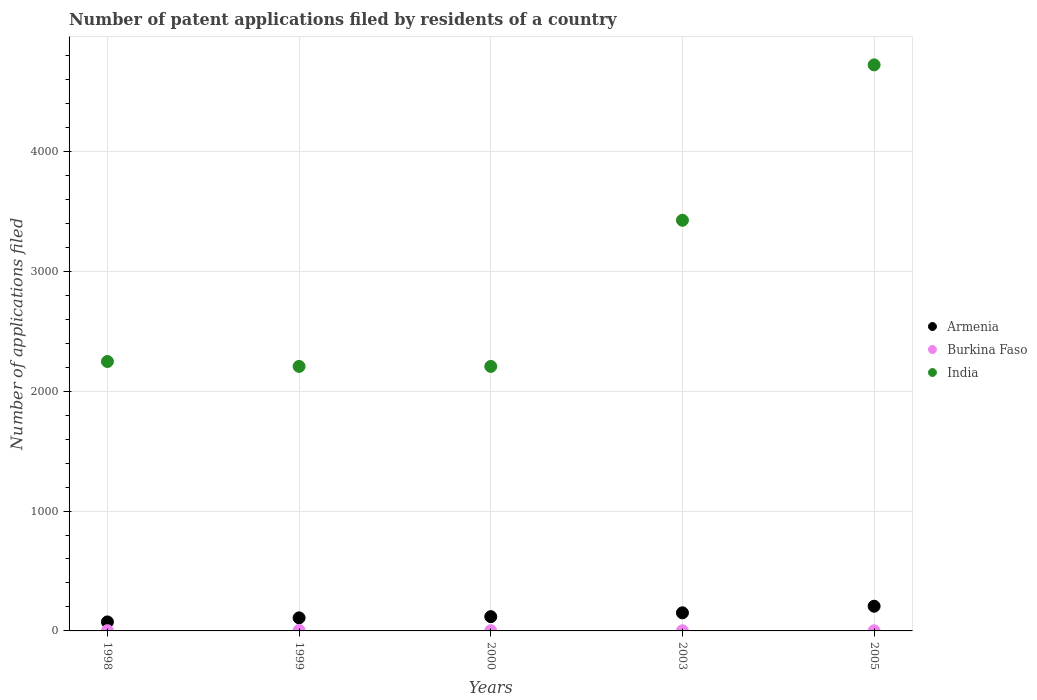How many different coloured dotlines are there?
Your answer should be compact. 3. Is the number of dotlines equal to the number of legend labels?
Your answer should be compact. Yes. What is the number of applications filed in Armenia in 2005?
Offer a terse response. 206. Across all years, what is the maximum number of applications filed in India?
Provide a short and direct response. 4721. What is the total number of applications filed in Burkina Faso in the graph?
Offer a terse response. 10. What is the difference between the number of applications filed in India in 2003 and the number of applications filed in Burkina Faso in 1999?
Provide a succinct answer. 3421. In the year 2005, what is the difference between the number of applications filed in India and number of applications filed in Armenia?
Provide a succinct answer. 4515. In how many years, is the number of applications filed in India greater than 800?
Offer a terse response. 5. What is the ratio of the number of applications filed in India in 2003 to that in 2005?
Ensure brevity in your answer.  0.73. Is the difference between the number of applications filed in India in 2003 and 2005 greater than the difference between the number of applications filed in Armenia in 2003 and 2005?
Make the answer very short. No. What is the difference between the highest and the second highest number of applications filed in India?
Ensure brevity in your answer.  1296. What is the difference between the highest and the lowest number of applications filed in Armenia?
Make the answer very short. 131. In how many years, is the number of applications filed in Burkina Faso greater than the average number of applications filed in Burkina Faso taken over all years?
Provide a short and direct response. 1. How many dotlines are there?
Offer a very short reply. 3. How many years are there in the graph?
Your response must be concise. 5. Are the values on the major ticks of Y-axis written in scientific E-notation?
Your answer should be compact. No. Does the graph contain any zero values?
Offer a very short reply. No. Where does the legend appear in the graph?
Offer a very short reply. Center right. What is the title of the graph?
Give a very brief answer. Number of patent applications filed by residents of a country. Does "Middle East & North Africa (all income levels)" appear as one of the legend labels in the graph?
Your response must be concise. No. What is the label or title of the Y-axis?
Give a very brief answer. Number of applications filed. What is the Number of applications filed of Armenia in 1998?
Your answer should be compact. 75. What is the Number of applications filed of India in 1998?
Keep it short and to the point. 2247. What is the Number of applications filed of Armenia in 1999?
Give a very brief answer. 109. What is the Number of applications filed of India in 1999?
Keep it short and to the point. 2206. What is the Number of applications filed of Armenia in 2000?
Give a very brief answer. 119. What is the Number of applications filed in India in 2000?
Provide a succinct answer. 2206. What is the Number of applications filed in Armenia in 2003?
Make the answer very short. 151. What is the Number of applications filed of Burkina Faso in 2003?
Give a very brief answer. 1. What is the Number of applications filed of India in 2003?
Provide a short and direct response. 3425. What is the Number of applications filed in Armenia in 2005?
Ensure brevity in your answer.  206. What is the Number of applications filed of India in 2005?
Make the answer very short. 4721. Across all years, what is the maximum Number of applications filed in Armenia?
Your response must be concise. 206. Across all years, what is the maximum Number of applications filed in Burkina Faso?
Keep it short and to the point. 4. Across all years, what is the maximum Number of applications filed in India?
Your response must be concise. 4721. Across all years, what is the minimum Number of applications filed of Burkina Faso?
Provide a short and direct response. 1. Across all years, what is the minimum Number of applications filed of India?
Provide a succinct answer. 2206. What is the total Number of applications filed of Armenia in the graph?
Offer a terse response. 660. What is the total Number of applications filed of India in the graph?
Provide a succinct answer. 1.48e+04. What is the difference between the Number of applications filed of Armenia in 1998 and that in 1999?
Provide a short and direct response. -34. What is the difference between the Number of applications filed of Armenia in 1998 and that in 2000?
Your response must be concise. -44. What is the difference between the Number of applications filed of Burkina Faso in 1998 and that in 2000?
Your response must be concise. 0. What is the difference between the Number of applications filed of Armenia in 1998 and that in 2003?
Keep it short and to the point. -76. What is the difference between the Number of applications filed in Burkina Faso in 1998 and that in 2003?
Offer a terse response. 1. What is the difference between the Number of applications filed of India in 1998 and that in 2003?
Your response must be concise. -1178. What is the difference between the Number of applications filed of Armenia in 1998 and that in 2005?
Provide a succinct answer. -131. What is the difference between the Number of applications filed in Burkina Faso in 1998 and that in 2005?
Your answer should be compact. 1. What is the difference between the Number of applications filed in India in 1998 and that in 2005?
Make the answer very short. -2474. What is the difference between the Number of applications filed in Armenia in 1999 and that in 2003?
Make the answer very short. -42. What is the difference between the Number of applications filed in Burkina Faso in 1999 and that in 2003?
Keep it short and to the point. 3. What is the difference between the Number of applications filed of India in 1999 and that in 2003?
Your response must be concise. -1219. What is the difference between the Number of applications filed of Armenia in 1999 and that in 2005?
Provide a succinct answer. -97. What is the difference between the Number of applications filed in India in 1999 and that in 2005?
Make the answer very short. -2515. What is the difference between the Number of applications filed of Armenia in 2000 and that in 2003?
Your answer should be very brief. -32. What is the difference between the Number of applications filed in Burkina Faso in 2000 and that in 2003?
Give a very brief answer. 1. What is the difference between the Number of applications filed of India in 2000 and that in 2003?
Offer a terse response. -1219. What is the difference between the Number of applications filed in Armenia in 2000 and that in 2005?
Keep it short and to the point. -87. What is the difference between the Number of applications filed in India in 2000 and that in 2005?
Provide a short and direct response. -2515. What is the difference between the Number of applications filed of Armenia in 2003 and that in 2005?
Provide a succinct answer. -55. What is the difference between the Number of applications filed of India in 2003 and that in 2005?
Keep it short and to the point. -1296. What is the difference between the Number of applications filed of Armenia in 1998 and the Number of applications filed of India in 1999?
Give a very brief answer. -2131. What is the difference between the Number of applications filed of Burkina Faso in 1998 and the Number of applications filed of India in 1999?
Provide a short and direct response. -2204. What is the difference between the Number of applications filed in Armenia in 1998 and the Number of applications filed in Burkina Faso in 2000?
Your answer should be very brief. 73. What is the difference between the Number of applications filed in Armenia in 1998 and the Number of applications filed in India in 2000?
Your answer should be compact. -2131. What is the difference between the Number of applications filed in Burkina Faso in 1998 and the Number of applications filed in India in 2000?
Give a very brief answer. -2204. What is the difference between the Number of applications filed in Armenia in 1998 and the Number of applications filed in Burkina Faso in 2003?
Provide a succinct answer. 74. What is the difference between the Number of applications filed in Armenia in 1998 and the Number of applications filed in India in 2003?
Ensure brevity in your answer.  -3350. What is the difference between the Number of applications filed of Burkina Faso in 1998 and the Number of applications filed of India in 2003?
Offer a very short reply. -3423. What is the difference between the Number of applications filed of Armenia in 1998 and the Number of applications filed of Burkina Faso in 2005?
Provide a short and direct response. 74. What is the difference between the Number of applications filed of Armenia in 1998 and the Number of applications filed of India in 2005?
Your response must be concise. -4646. What is the difference between the Number of applications filed of Burkina Faso in 1998 and the Number of applications filed of India in 2005?
Provide a short and direct response. -4719. What is the difference between the Number of applications filed in Armenia in 1999 and the Number of applications filed in Burkina Faso in 2000?
Give a very brief answer. 107. What is the difference between the Number of applications filed of Armenia in 1999 and the Number of applications filed of India in 2000?
Your answer should be very brief. -2097. What is the difference between the Number of applications filed in Burkina Faso in 1999 and the Number of applications filed in India in 2000?
Ensure brevity in your answer.  -2202. What is the difference between the Number of applications filed in Armenia in 1999 and the Number of applications filed in Burkina Faso in 2003?
Your answer should be very brief. 108. What is the difference between the Number of applications filed of Armenia in 1999 and the Number of applications filed of India in 2003?
Your answer should be very brief. -3316. What is the difference between the Number of applications filed of Burkina Faso in 1999 and the Number of applications filed of India in 2003?
Provide a short and direct response. -3421. What is the difference between the Number of applications filed in Armenia in 1999 and the Number of applications filed in Burkina Faso in 2005?
Offer a terse response. 108. What is the difference between the Number of applications filed of Armenia in 1999 and the Number of applications filed of India in 2005?
Offer a very short reply. -4612. What is the difference between the Number of applications filed in Burkina Faso in 1999 and the Number of applications filed in India in 2005?
Your response must be concise. -4717. What is the difference between the Number of applications filed in Armenia in 2000 and the Number of applications filed in Burkina Faso in 2003?
Your answer should be compact. 118. What is the difference between the Number of applications filed in Armenia in 2000 and the Number of applications filed in India in 2003?
Keep it short and to the point. -3306. What is the difference between the Number of applications filed of Burkina Faso in 2000 and the Number of applications filed of India in 2003?
Make the answer very short. -3423. What is the difference between the Number of applications filed in Armenia in 2000 and the Number of applications filed in Burkina Faso in 2005?
Provide a succinct answer. 118. What is the difference between the Number of applications filed of Armenia in 2000 and the Number of applications filed of India in 2005?
Offer a terse response. -4602. What is the difference between the Number of applications filed of Burkina Faso in 2000 and the Number of applications filed of India in 2005?
Provide a succinct answer. -4719. What is the difference between the Number of applications filed of Armenia in 2003 and the Number of applications filed of Burkina Faso in 2005?
Offer a very short reply. 150. What is the difference between the Number of applications filed in Armenia in 2003 and the Number of applications filed in India in 2005?
Offer a terse response. -4570. What is the difference between the Number of applications filed in Burkina Faso in 2003 and the Number of applications filed in India in 2005?
Ensure brevity in your answer.  -4720. What is the average Number of applications filed in Armenia per year?
Your response must be concise. 132. What is the average Number of applications filed in India per year?
Your answer should be very brief. 2961. In the year 1998, what is the difference between the Number of applications filed in Armenia and Number of applications filed in Burkina Faso?
Make the answer very short. 73. In the year 1998, what is the difference between the Number of applications filed in Armenia and Number of applications filed in India?
Give a very brief answer. -2172. In the year 1998, what is the difference between the Number of applications filed in Burkina Faso and Number of applications filed in India?
Provide a succinct answer. -2245. In the year 1999, what is the difference between the Number of applications filed in Armenia and Number of applications filed in Burkina Faso?
Offer a terse response. 105. In the year 1999, what is the difference between the Number of applications filed in Armenia and Number of applications filed in India?
Offer a terse response. -2097. In the year 1999, what is the difference between the Number of applications filed of Burkina Faso and Number of applications filed of India?
Offer a very short reply. -2202. In the year 2000, what is the difference between the Number of applications filed in Armenia and Number of applications filed in Burkina Faso?
Ensure brevity in your answer.  117. In the year 2000, what is the difference between the Number of applications filed of Armenia and Number of applications filed of India?
Your answer should be very brief. -2087. In the year 2000, what is the difference between the Number of applications filed in Burkina Faso and Number of applications filed in India?
Make the answer very short. -2204. In the year 2003, what is the difference between the Number of applications filed of Armenia and Number of applications filed of Burkina Faso?
Your response must be concise. 150. In the year 2003, what is the difference between the Number of applications filed in Armenia and Number of applications filed in India?
Your answer should be compact. -3274. In the year 2003, what is the difference between the Number of applications filed of Burkina Faso and Number of applications filed of India?
Offer a very short reply. -3424. In the year 2005, what is the difference between the Number of applications filed in Armenia and Number of applications filed in Burkina Faso?
Your answer should be very brief. 205. In the year 2005, what is the difference between the Number of applications filed of Armenia and Number of applications filed of India?
Provide a succinct answer. -4515. In the year 2005, what is the difference between the Number of applications filed of Burkina Faso and Number of applications filed of India?
Offer a terse response. -4720. What is the ratio of the Number of applications filed in Armenia in 1998 to that in 1999?
Keep it short and to the point. 0.69. What is the ratio of the Number of applications filed of India in 1998 to that in 1999?
Your answer should be compact. 1.02. What is the ratio of the Number of applications filed of Armenia in 1998 to that in 2000?
Offer a very short reply. 0.63. What is the ratio of the Number of applications filed of India in 1998 to that in 2000?
Offer a very short reply. 1.02. What is the ratio of the Number of applications filed of Armenia in 1998 to that in 2003?
Your response must be concise. 0.5. What is the ratio of the Number of applications filed of Burkina Faso in 1998 to that in 2003?
Offer a very short reply. 2. What is the ratio of the Number of applications filed of India in 1998 to that in 2003?
Make the answer very short. 0.66. What is the ratio of the Number of applications filed of Armenia in 1998 to that in 2005?
Your answer should be very brief. 0.36. What is the ratio of the Number of applications filed of Burkina Faso in 1998 to that in 2005?
Offer a terse response. 2. What is the ratio of the Number of applications filed in India in 1998 to that in 2005?
Give a very brief answer. 0.48. What is the ratio of the Number of applications filed of Armenia in 1999 to that in 2000?
Your answer should be very brief. 0.92. What is the ratio of the Number of applications filed in Burkina Faso in 1999 to that in 2000?
Your answer should be compact. 2. What is the ratio of the Number of applications filed in India in 1999 to that in 2000?
Keep it short and to the point. 1. What is the ratio of the Number of applications filed of Armenia in 1999 to that in 2003?
Provide a succinct answer. 0.72. What is the ratio of the Number of applications filed in India in 1999 to that in 2003?
Provide a succinct answer. 0.64. What is the ratio of the Number of applications filed in Armenia in 1999 to that in 2005?
Provide a short and direct response. 0.53. What is the ratio of the Number of applications filed of India in 1999 to that in 2005?
Your answer should be compact. 0.47. What is the ratio of the Number of applications filed of Armenia in 2000 to that in 2003?
Your answer should be very brief. 0.79. What is the ratio of the Number of applications filed of India in 2000 to that in 2003?
Provide a succinct answer. 0.64. What is the ratio of the Number of applications filed in Armenia in 2000 to that in 2005?
Provide a short and direct response. 0.58. What is the ratio of the Number of applications filed in Burkina Faso in 2000 to that in 2005?
Offer a terse response. 2. What is the ratio of the Number of applications filed in India in 2000 to that in 2005?
Offer a terse response. 0.47. What is the ratio of the Number of applications filed in Armenia in 2003 to that in 2005?
Keep it short and to the point. 0.73. What is the ratio of the Number of applications filed of Burkina Faso in 2003 to that in 2005?
Your answer should be compact. 1. What is the ratio of the Number of applications filed in India in 2003 to that in 2005?
Your answer should be compact. 0.73. What is the difference between the highest and the second highest Number of applications filed in Armenia?
Ensure brevity in your answer.  55. What is the difference between the highest and the second highest Number of applications filed in India?
Provide a short and direct response. 1296. What is the difference between the highest and the lowest Number of applications filed in Armenia?
Offer a very short reply. 131. What is the difference between the highest and the lowest Number of applications filed in Burkina Faso?
Give a very brief answer. 3. What is the difference between the highest and the lowest Number of applications filed of India?
Provide a short and direct response. 2515. 